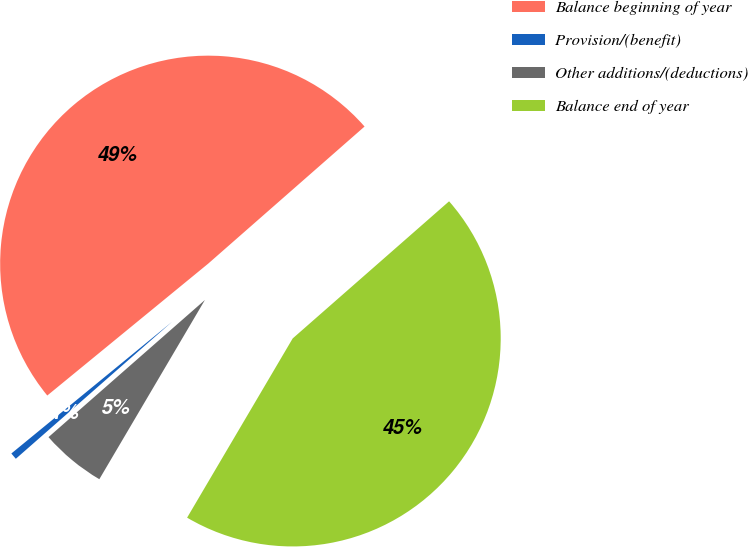<chart> <loc_0><loc_0><loc_500><loc_500><pie_chart><fcel>Balance beginning of year<fcel>Provision/(benefit)<fcel>Other additions/(deductions)<fcel>Balance end of year<nl><fcel>49.47%<fcel>0.53%<fcel>5.07%<fcel>44.93%<nl></chart> 